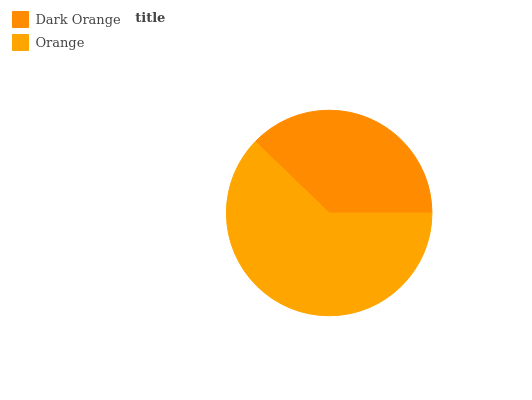Is Dark Orange the minimum?
Answer yes or no. Yes. Is Orange the maximum?
Answer yes or no. Yes. Is Orange the minimum?
Answer yes or no. No. Is Orange greater than Dark Orange?
Answer yes or no. Yes. Is Dark Orange less than Orange?
Answer yes or no. Yes. Is Dark Orange greater than Orange?
Answer yes or no. No. Is Orange less than Dark Orange?
Answer yes or no. No. Is Orange the high median?
Answer yes or no. Yes. Is Dark Orange the low median?
Answer yes or no. Yes. Is Dark Orange the high median?
Answer yes or no. No. Is Orange the low median?
Answer yes or no. No. 